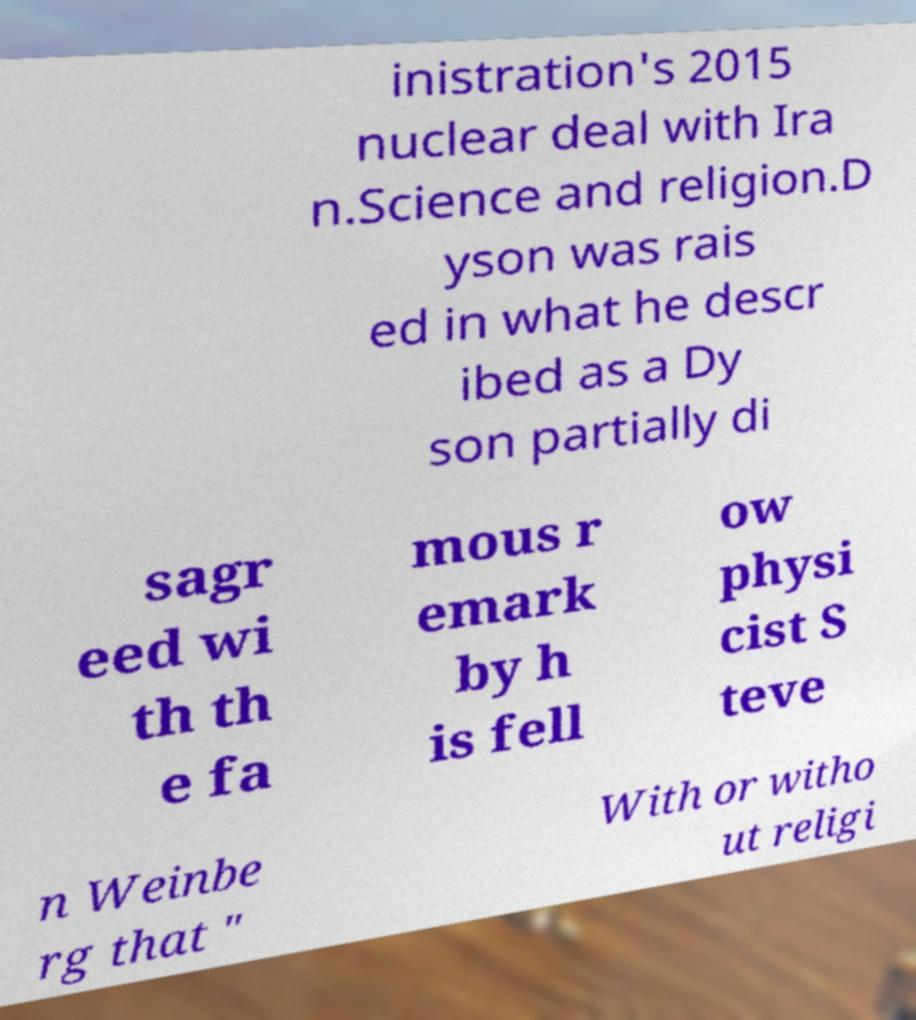Can you accurately transcribe the text from the provided image for me? inistration's 2015 nuclear deal with Ira n.Science and religion.D yson was rais ed in what he descr ibed as a Dy son partially di sagr eed wi th th e fa mous r emark by h is fell ow physi cist S teve n Weinbe rg that " With or witho ut religi 